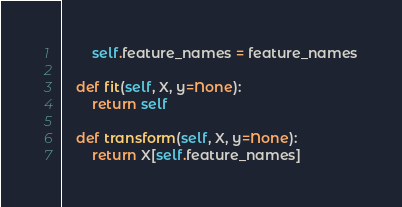<code> <loc_0><loc_0><loc_500><loc_500><_Python_>        self.feature_names = feature_names

    def fit(self, X, y=None):
        return self

    def transform(self, X, y=None):
        return X[self.feature_names]
</code> 